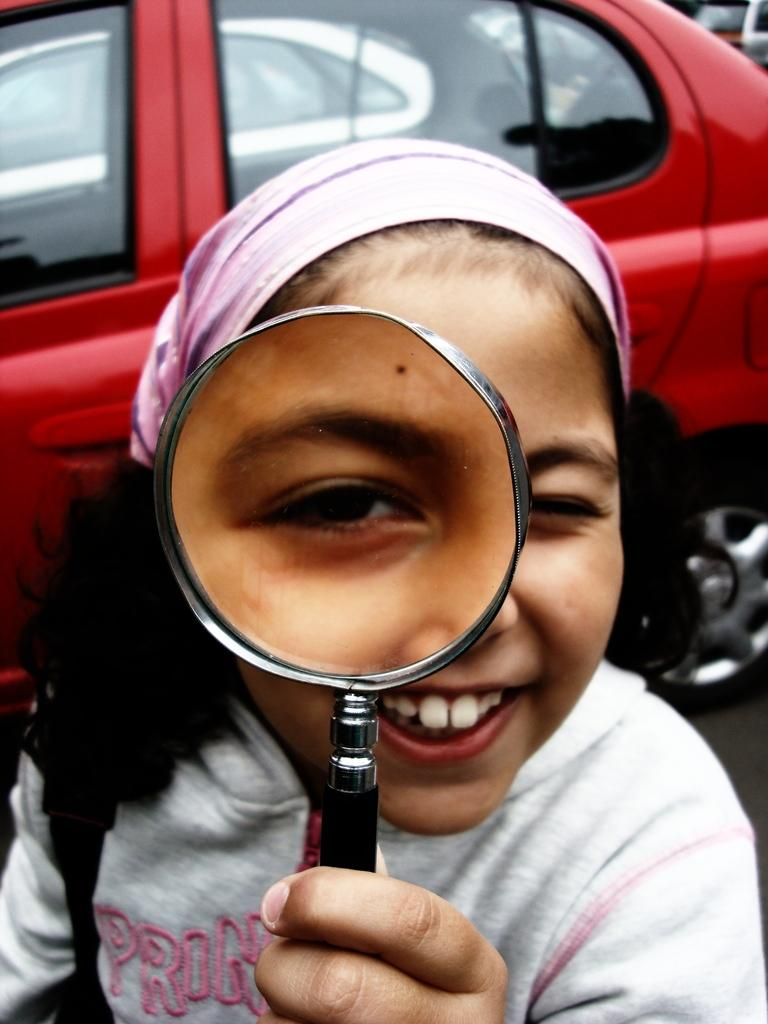What is the person in the image doing? The person is standing in the image. What object is the person holding in her hand? The person is holding a magnifying glass in her hand. What can be seen in the background of the image? There is a red-colored car visible in the image. Is the person in the image sleeping or wearing a brass ring? The person in the image is not sleeping, and there is no brass ring visible. 